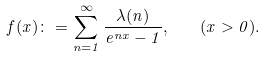Convert formula to latex. <formula><loc_0><loc_0><loc_500><loc_500>f ( x ) \colon = \sum _ { n = 1 } ^ { \infty } \frac { \lambda ( n ) } { e ^ { n x } - 1 } , \quad ( x > 0 ) .</formula> 